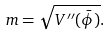<formula> <loc_0><loc_0><loc_500><loc_500>m = \sqrt { V ^ { \prime \prime } ( \bar { \phi } ) } .</formula> 